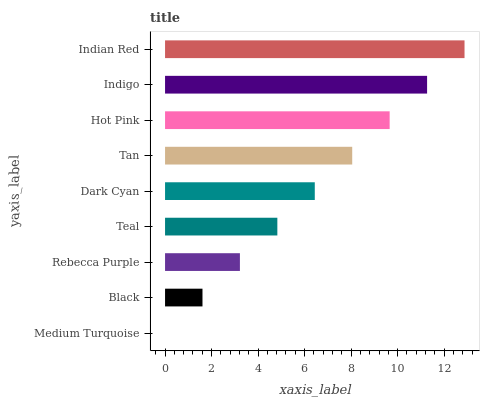Is Medium Turquoise the minimum?
Answer yes or no. Yes. Is Indian Red the maximum?
Answer yes or no. Yes. Is Black the minimum?
Answer yes or no. No. Is Black the maximum?
Answer yes or no. No. Is Black greater than Medium Turquoise?
Answer yes or no. Yes. Is Medium Turquoise less than Black?
Answer yes or no. Yes. Is Medium Turquoise greater than Black?
Answer yes or no. No. Is Black less than Medium Turquoise?
Answer yes or no. No. Is Dark Cyan the high median?
Answer yes or no. Yes. Is Dark Cyan the low median?
Answer yes or no. Yes. Is Indian Red the high median?
Answer yes or no. No. Is Teal the low median?
Answer yes or no. No. 